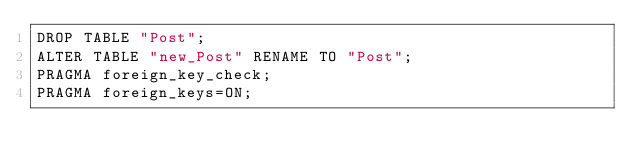<code> <loc_0><loc_0><loc_500><loc_500><_SQL_>DROP TABLE "Post";
ALTER TABLE "new_Post" RENAME TO "Post";
PRAGMA foreign_key_check;
PRAGMA foreign_keys=ON;
</code> 